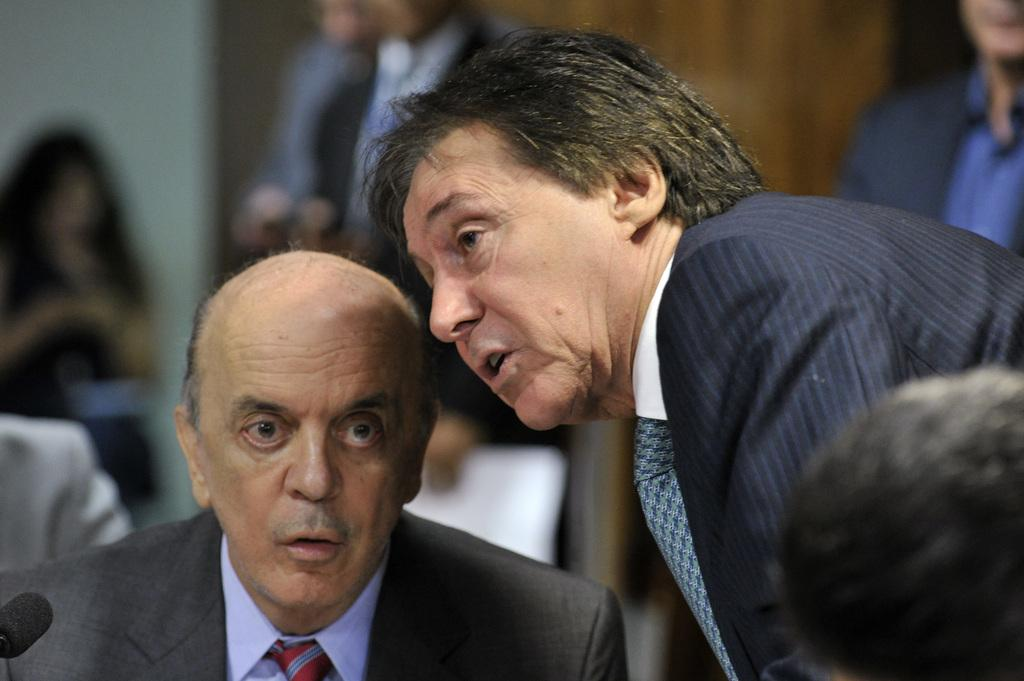How many people are in the image? There are people in the image, but the exact number is not specified. What are the people in the image doing? Some people are sitting, while others are standing. What object can be seen in the image that is typically used for amplifying sound? There is a mic in the image. Can you describe the background of the image? The background is blurred. What type of locket is hanging from the neck of the person in the image? There is no locket visible in the image. How many books can be seen on the table in the image? There is no table or books present in the image. 